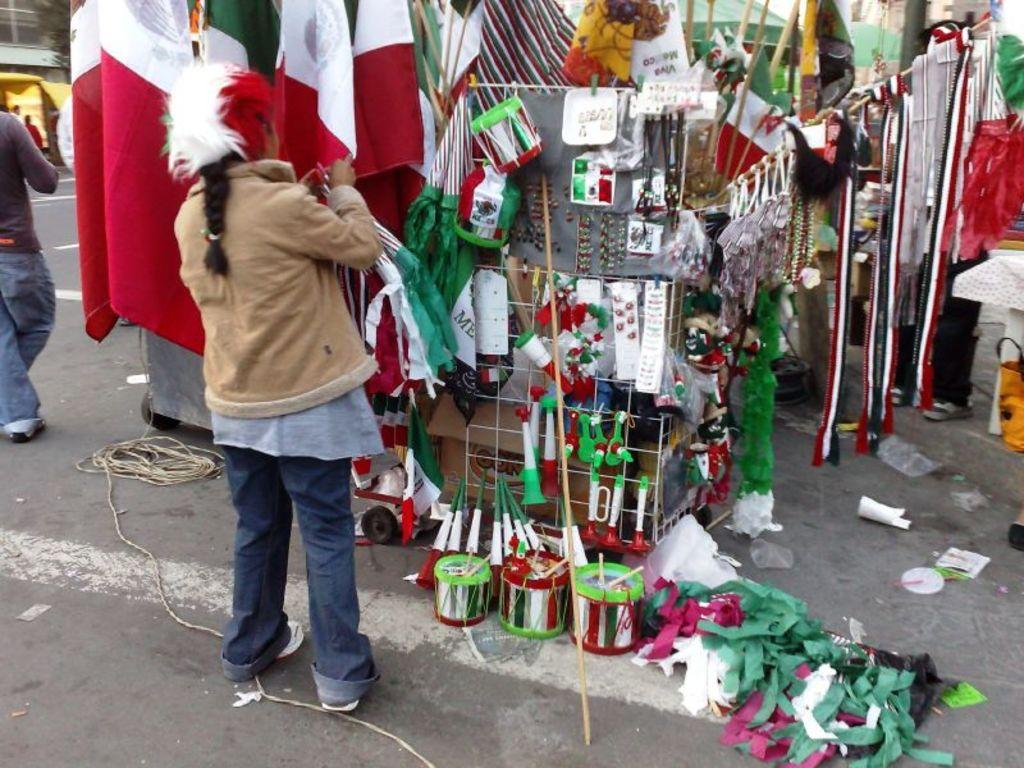What are the people in the image doing? The people in the image are standing on the road. What objects are on the ground near the people? There are drums and flags on the ground. What type of rice is being cooked in the background of the image? There is no rice present in the image; it features people standing on the road with drums and flags on the ground. 